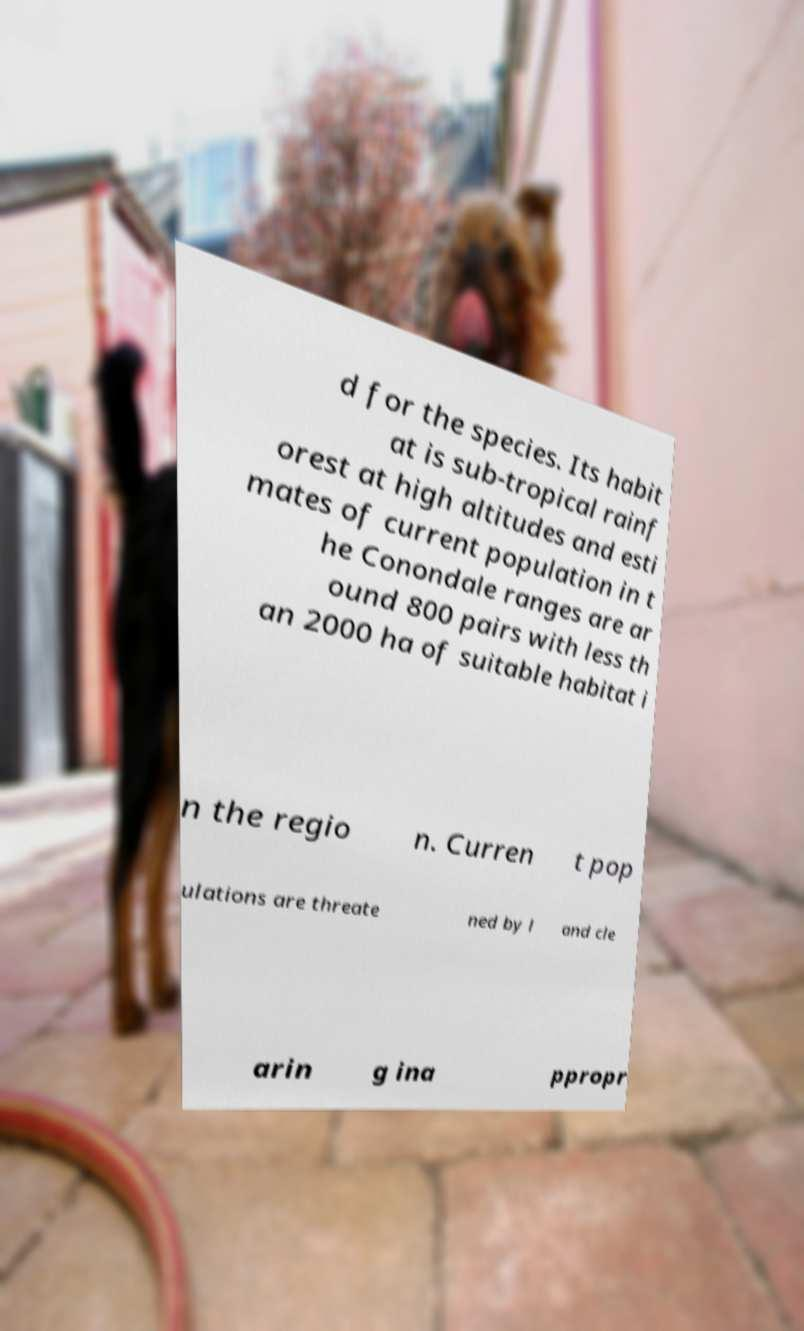Please identify and transcribe the text found in this image. d for the species. Its habit at is sub-tropical rainf orest at high altitudes and esti mates of current population in t he Conondale ranges are ar ound 800 pairs with less th an 2000 ha of suitable habitat i n the regio n. Curren t pop ulations are threate ned by l and cle arin g ina ppropr 